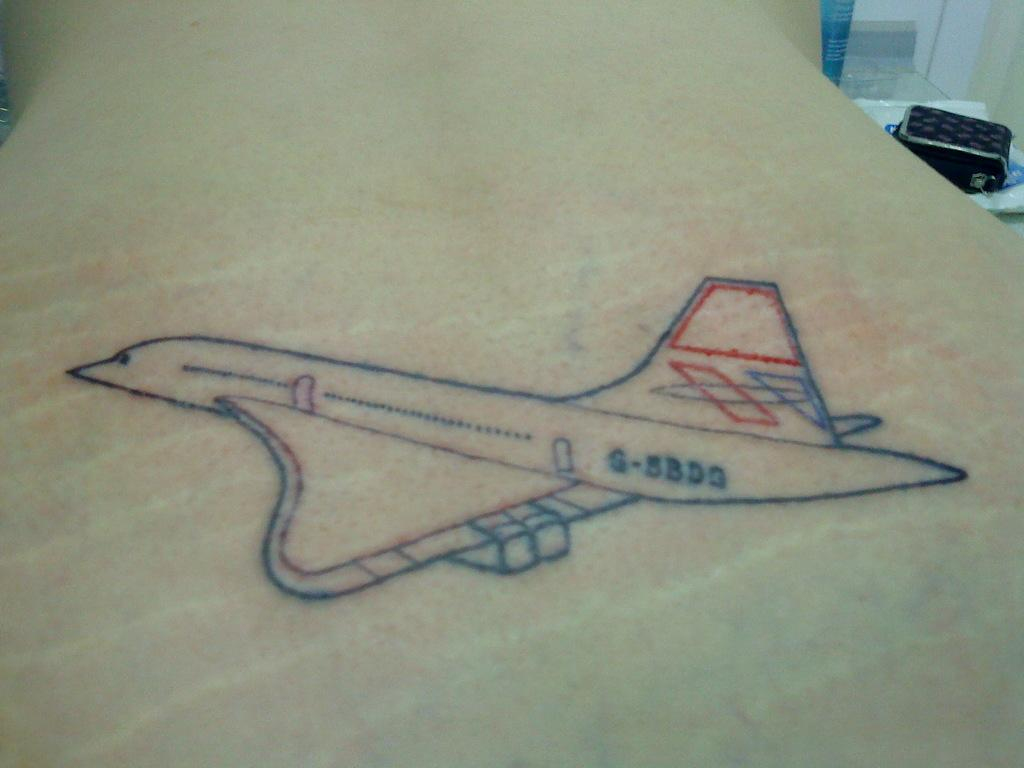What design is featured on the couch in the image? There is a jet plane design on the couch. What objects can be seen on the table in the top right corner of the image? There are boxes on the table in the top right corner of the image. How many pickles are on the couch in the image? There are no pickles present in the image; the design on the couch features a jet plane. What color are the cherries on the table in the image? There are no cherries present in the image; the objects on the table are boxes. 